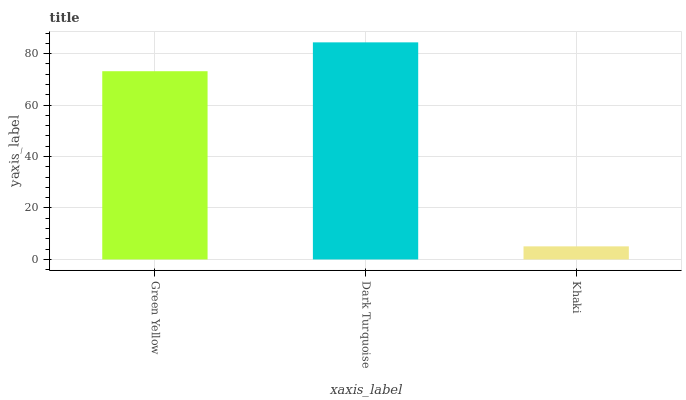Is Khaki the minimum?
Answer yes or no. Yes. Is Dark Turquoise the maximum?
Answer yes or no. Yes. Is Dark Turquoise the minimum?
Answer yes or no. No. Is Khaki the maximum?
Answer yes or no. No. Is Dark Turquoise greater than Khaki?
Answer yes or no. Yes. Is Khaki less than Dark Turquoise?
Answer yes or no. Yes. Is Khaki greater than Dark Turquoise?
Answer yes or no. No. Is Dark Turquoise less than Khaki?
Answer yes or no. No. Is Green Yellow the high median?
Answer yes or no. Yes. Is Green Yellow the low median?
Answer yes or no. Yes. Is Dark Turquoise the high median?
Answer yes or no. No. Is Khaki the low median?
Answer yes or no. No. 